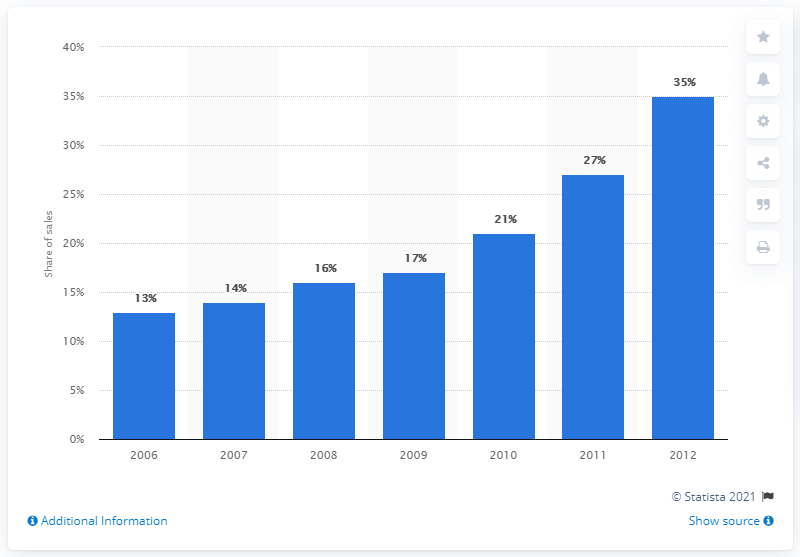Indicate a few pertinent items in this graphic. In the year 2010, the Asia Pacific region accounted for more than 20 percent of elevator and escalator sales. 